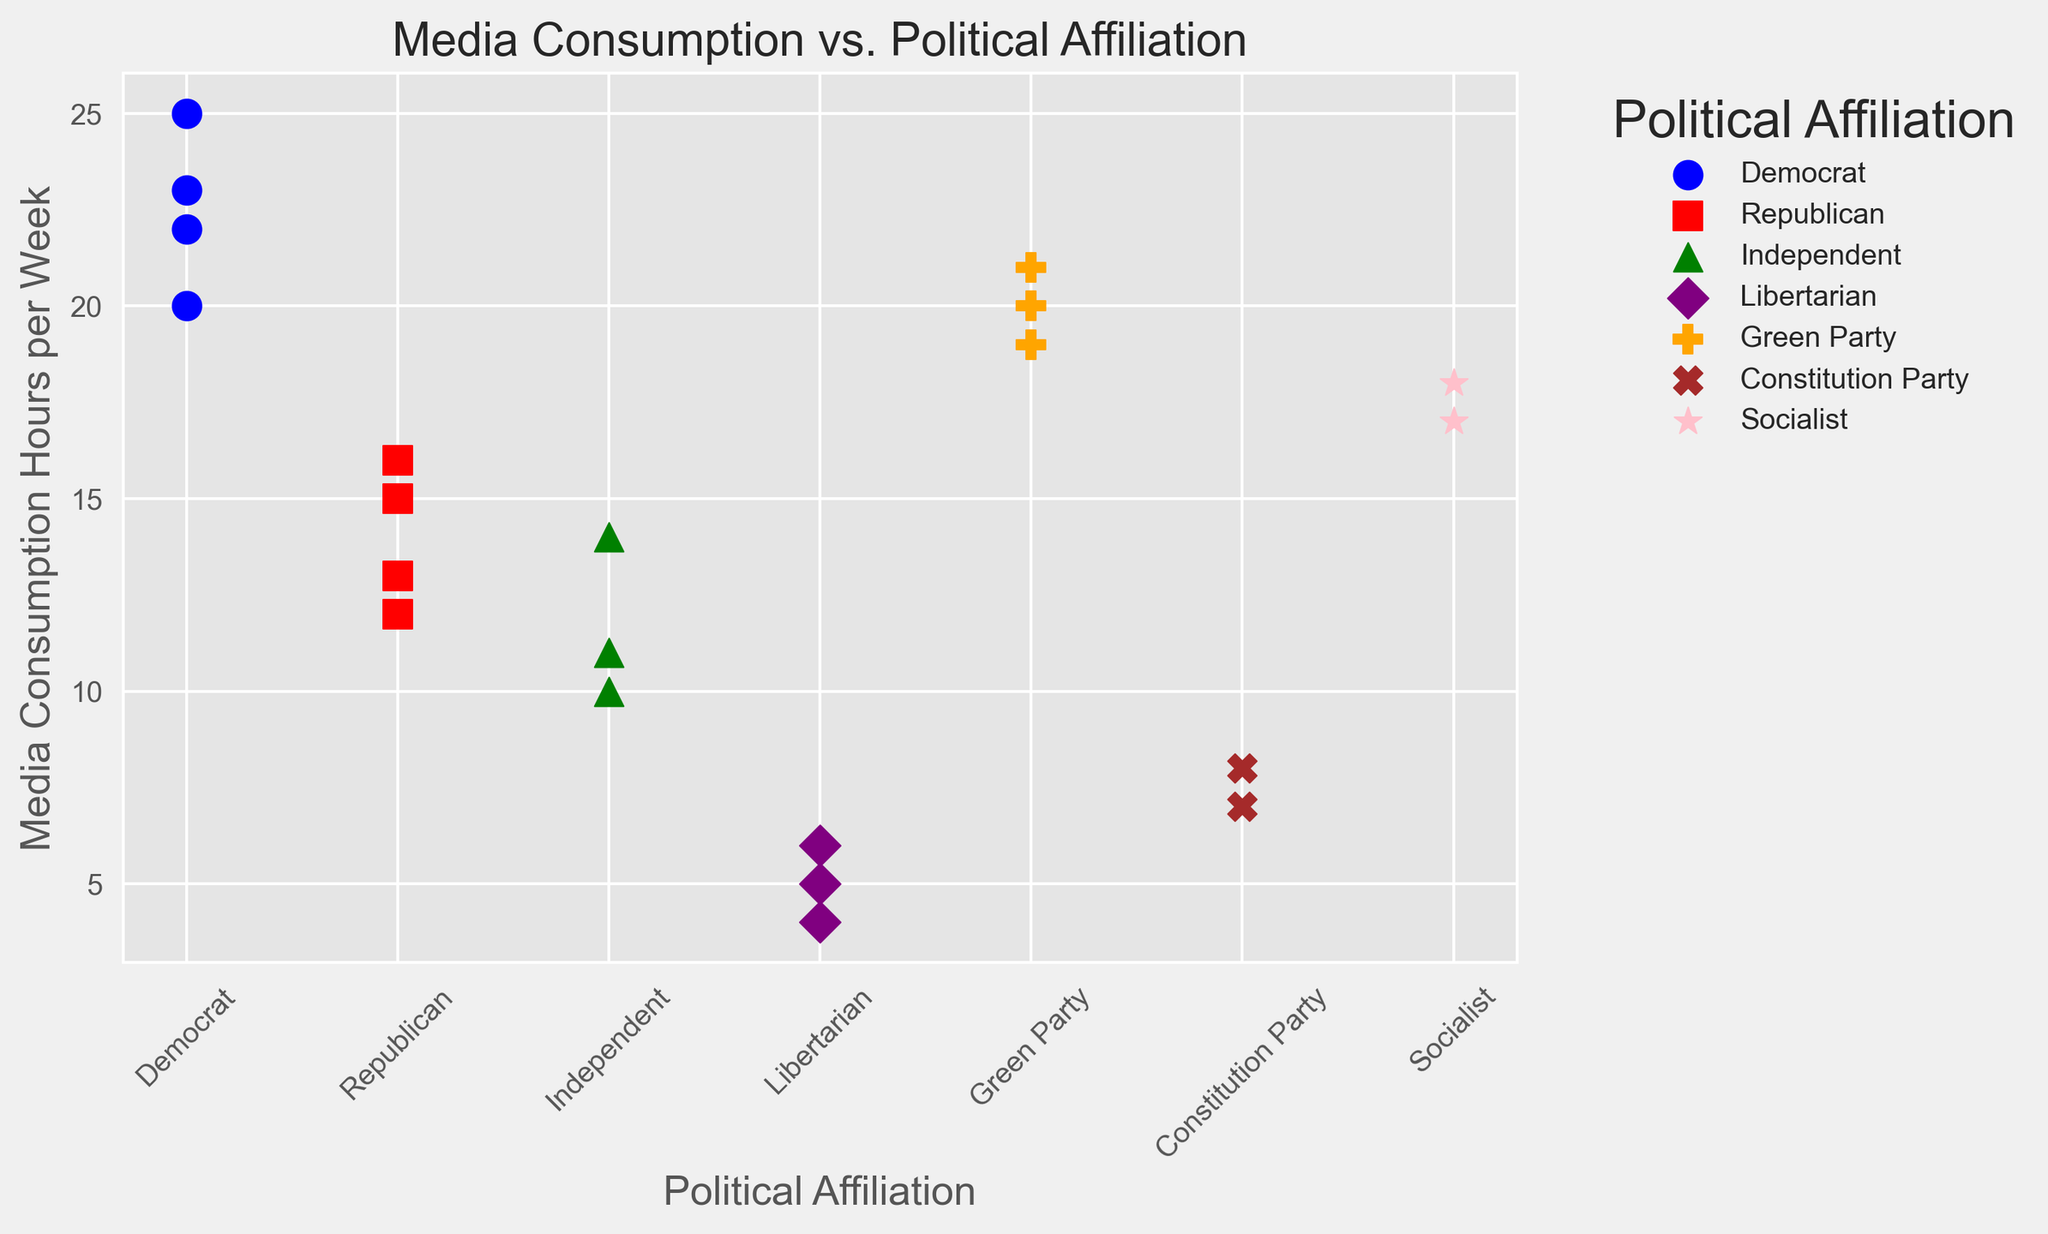What is the range of media consumption hours for Democrats? To find the range, subtract the smallest value from the largest value for Democrats. The values provided are 20, 22, 23, and 25. Thus, the range is 25 - 20.
Answer: 5 Which political affiliation has the lowest average media consumption hours per week? Calculate the average media consumption for each political affiliation and compare them. Libertarian's average is (5 + 6 + 4) / 3 = 5.
Answer: Libertarian Among the specified political affiliations, which group shows the highest media consumption hour visually? By checking the maximum data point for each group, we see that the highest point belongs to the Democrats with 25 hours.
Answer: Democrat How many affiliations have an average media consumption greater than 15 hours per week? Calculate the average for each group. Democrats, Green Party, and Socialist have average consumption above 15 hours.
Answer: 3 Compare the median media consumption hours per week between Democrats and Republicans. Which is higher? The median for Democrats (20, 22, 23, 25) is the average of the middle two values, (22+23)/2 = 22.5. For Republicans (12, 13, 15, 16), it's (13+15)/2 = 14.
Answer: Democrat What is the sum of media consumption hours per week for the Green Party? Add up all data points for the Green Party: 20 + 19 + 21. The sum is 60.
Answer: 60 Which party shows a greater spread in media consumption hours, Democrats or Republicans? For spread, calculate the range. Democrats have a range of 5 (25-20=5) while Republicans have a range of 4 (16-12=4).
Answer: Democrat Are there any parties with identical media consumption hours per any given week? Scan the data points for any duplications across the different affiliations. No two affiliations share the exact same values.
Answer: No Which group has the second-lowest media consumption hours visually? By visually scanning and arranging the dots on the scatter plot, Libertarians have (5, 6, 4), Constitution Party has 7 and 8, and the second-lowest among them is the Constitution Party with 7 hours.
Answer: Constitution Party What is the difference between the maximum media consumption hours and the minimum media consumption hours? Identify the maximum (25 for Democrat) and the minimum (4 for Libertarian) and calculate the difference: 25 - 4.
Answer: 21 